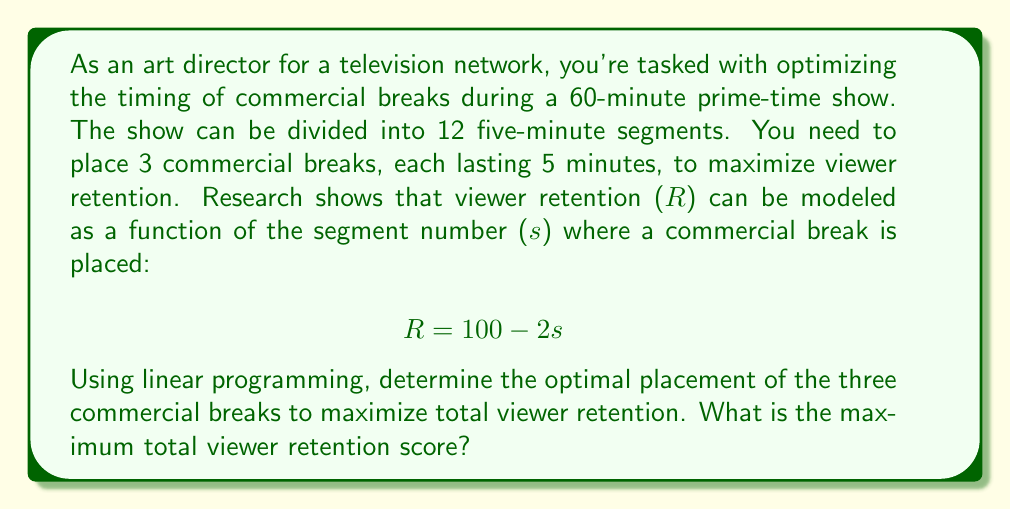Solve this math problem. Let's approach this step-by-step using linear programming:

1) Define variables:
   Let $x_i$ be a binary variable where $x_i = 1$ if a commercial break is placed after segment $i$, and 0 otherwise.

2) Objective function:
   We want to maximize the total retention, which is the sum of retentions for each break:
   $$\text{Maximize } Z = \sum_{i=1}^{11} (100 - 2i)x_i$$

3) Constraints:
   a) We need exactly 3 commercial breaks:
      $$\sum_{i=1}^{11} x_i = 3$$
   
   b) Binary constraint:
      $$x_i \in \{0,1\} \text{ for } i = 1, 2, ..., 11$$

4) Solve:
   This is an integer programming problem. The optimal solution will place breaks after segments with the highest retention scores, which are the earliest possible segments:
   
   After segment 1: $R = 100 - 2(1) = 98$
   After segment 2: $R = 100 - 2(2) = 96$
   After segment 3: $R = 100 - 2(3) = 94$

5) Calculate total retention:
   Total retention = 98 + 96 + 94 = 288
Answer: The maximum total viewer retention score is 288. 